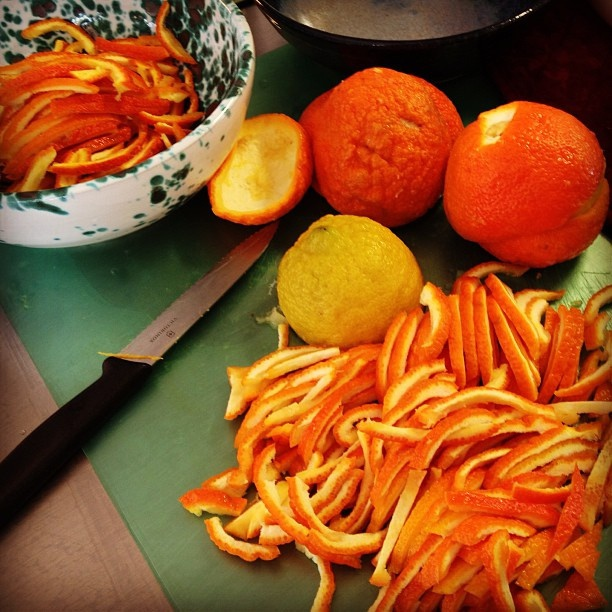Describe the objects in this image and their specific colors. I can see dining table in darkgreen, black, red, and orange tones, bowl in darkgreen, brown, black, red, and darkgray tones, orange in darkgreen, red, brown, and maroon tones, bowl in darkgreen, black, brown, gray, and maroon tones, and orange in darkgreen, red, brown, and maroon tones in this image. 